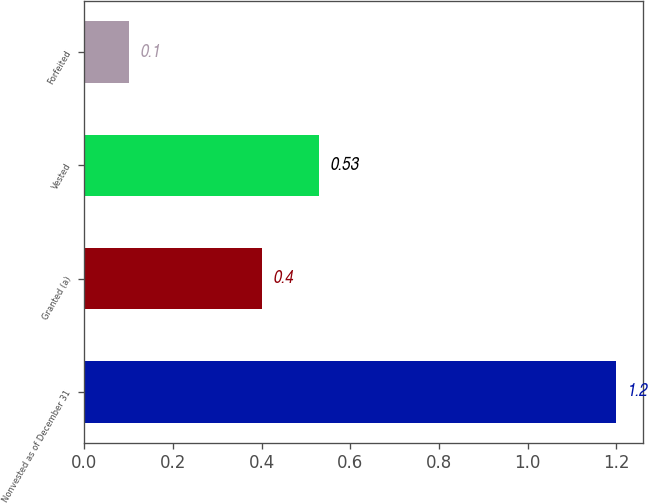<chart> <loc_0><loc_0><loc_500><loc_500><bar_chart><fcel>Nonvested as of December 31<fcel>Granted (a)<fcel>Vested<fcel>Forfeited<nl><fcel>1.2<fcel>0.4<fcel>0.53<fcel>0.1<nl></chart> 